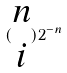<formula> <loc_0><loc_0><loc_500><loc_500>( \begin{matrix} n \\ i \end{matrix} ) 2 ^ { - n }</formula> 